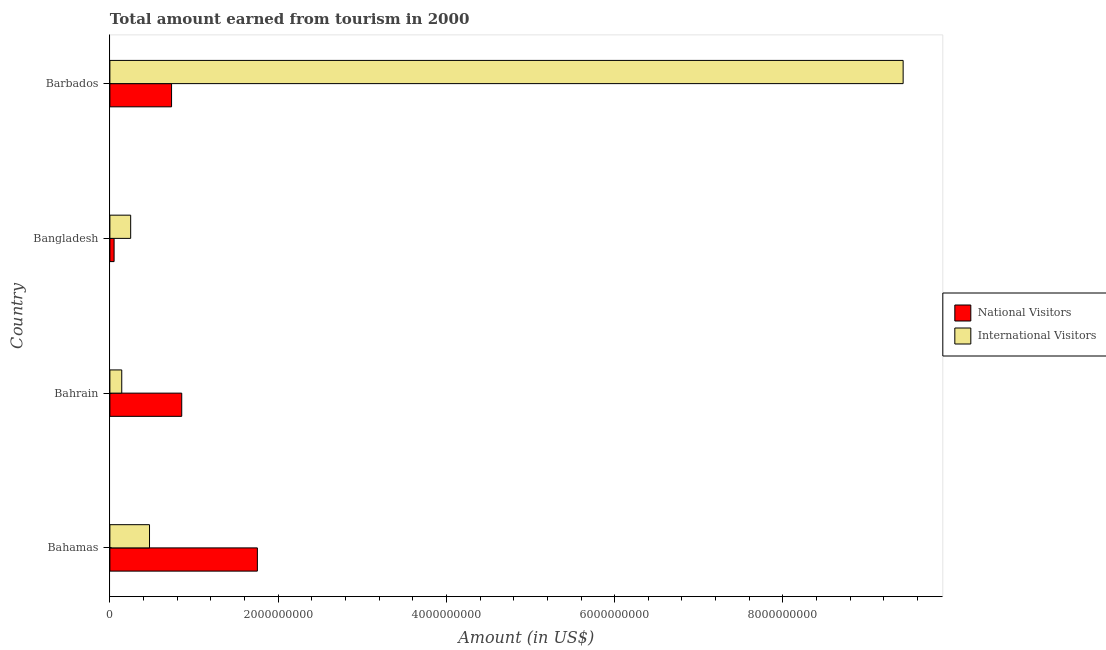How many groups of bars are there?
Your response must be concise. 4. Are the number of bars per tick equal to the number of legend labels?
Offer a very short reply. Yes. Are the number of bars on each tick of the Y-axis equal?
Your answer should be very brief. Yes. How many bars are there on the 4th tick from the top?
Make the answer very short. 2. What is the amount earned from national visitors in Bahamas?
Your response must be concise. 1.75e+09. Across all countries, what is the maximum amount earned from national visitors?
Your answer should be very brief. 1.75e+09. Across all countries, what is the minimum amount earned from international visitors?
Keep it short and to the point. 1.41e+08. In which country was the amount earned from international visitors maximum?
Offer a terse response. Barbados. In which country was the amount earned from national visitors minimum?
Make the answer very short. Bangladesh. What is the total amount earned from national visitors in the graph?
Offer a very short reply. 3.39e+09. What is the difference between the amount earned from national visitors in Bahamas and that in Bahrain?
Ensure brevity in your answer.  8.99e+08. What is the difference between the amount earned from national visitors in Bangladesh and the amount earned from international visitors in Bahamas?
Provide a short and direct response. -4.21e+08. What is the average amount earned from international visitors per country?
Ensure brevity in your answer.  2.57e+09. What is the difference between the amount earned from international visitors and amount earned from national visitors in Bahamas?
Offer a very short reply. -1.28e+09. What is the ratio of the amount earned from national visitors in Bahamas to that in Bangladesh?
Your answer should be compact. 35.06. Is the difference between the amount earned from international visitors in Bahamas and Bahrain greater than the difference between the amount earned from national visitors in Bahamas and Bahrain?
Provide a succinct answer. No. What is the difference between the highest and the second highest amount earned from national visitors?
Your response must be concise. 8.99e+08. What is the difference between the highest and the lowest amount earned from international visitors?
Provide a succinct answer. 9.29e+09. In how many countries, is the amount earned from international visitors greater than the average amount earned from international visitors taken over all countries?
Offer a terse response. 1. Is the sum of the amount earned from national visitors in Bangladesh and Barbados greater than the maximum amount earned from international visitors across all countries?
Make the answer very short. No. What does the 1st bar from the top in Bahamas represents?
Keep it short and to the point. International Visitors. What does the 2nd bar from the bottom in Bahamas represents?
Keep it short and to the point. International Visitors. What is the difference between two consecutive major ticks on the X-axis?
Your response must be concise. 2.00e+09. Are the values on the major ticks of X-axis written in scientific E-notation?
Keep it short and to the point. No. How many legend labels are there?
Provide a short and direct response. 2. How are the legend labels stacked?
Provide a short and direct response. Vertical. What is the title of the graph?
Your response must be concise. Total amount earned from tourism in 2000. What is the label or title of the X-axis?
Give a very brief answer. Amount (in US$). What is the Amount (in US$) of National Visitors in Bahamas?
Your answer should be compact. 1.75e+09. What is the Amount (in US$) of International Visitors in Bahamas?
Ensure brevity in your answer.  4.71e+08. What is the Amount (in US$) in National Visitors in Bahrain?
Offer a very short reply. 8.54e+08. What is the Amount (in US$) of International Visitors in Bahrain?
Offer a very short reply. 1.41e+08. What is the Amount (in US$) of National Visitors in Bangladesh?
Ensure brevity in your answer.  5.00e+07. What is the Amount (in US$) of International Visitors in Bangladesh?
Your response must be concise. 2.47e+08. What is the Amount (in US$) in National Visitors in Barbados?
Make the answer very short. 7.33e+08. What is the Amount (in US$) of International Visitors in Barbados?
Give a very brief answer. 9.43e+09. Across all countries, what is the maximum Amount (in US$) of National Visitors?
Keep it short and to the point. 1.75e+09. Across all countries, what is the maximum Amount (in US$) in International Visitors?
Provide a succinct answer. 9.43e+09. Across all countries, what is the minimum Amount (in US$) in National Visitors?
Offer a terse response. 5.00e+07. Across all countries, what is the minimum Amount (in US$) of International Visitors?
Give a very brief answer. 1.41e+08. What is the total Amount (in US$) in National Visitors in the graph?
Offer a terse response. 3.39e+09. What is the total Amount (in US$) in International Visitors in the graph?
Your response must be concise. 1.03e+1. What is the difference between the Amount (in US$) of National Visitors in Bahamas and that in Bahrain?
Make the answer very short. 8.99e+08. What is the difference between the Amount (in US$) of International Visitors in Bahamas and that in Bahrain?
Your answer should be compact. 3.30e+08. What is the difference between the Amount (in US$) in National Visitors in Bahamas and that in Bangladesh?
Ensure brevity in your answer.  1.70e+09. What is the difference between the Amount (in US$) of International Visitors in Bahamas and that in Bangladesh?
Offer a terse response. 2.24e+08. What is the difference between the Amount (in US$) of National Visitors in Bahamas and that in Barbados?
Provide a succinct answer. 1.02e+09. What is the difference between the Amount (in US$) of International Visitors in Bahamas and that in Barbados?
Your response must be concise. -8.96e+09. What is the difference between the Amount (in US$) of National Visitors in Bahrain and that in Bangladesh?
Your answer should be compact. 8.04e+08. What is the difference between the Amount (in US$) of International Visitors in Bahrain and that in Bangladesh?
Provide a succinct answer. -1.06e+08. What is the difference between the Amount (in US$) of National Visitors in Bahrain and that in Barbados?
Your response must be concise. 1.21e+08. What is the difference between the Amount (in US$) of International Visitors in Bahrain and that in Barbados?
Make the answer very short. -9.29e+09. What is the difference between the Amount (in US$) in National Visitors in Bangladesh and that in Barbados?
Make the answer very short. -6.83e+08. What is the difference between the Amount (in US$) of International Visitors in Bangladesh and that in Barbados?
Your answer should be compact. -9.18e+09. What is the difference between the Amount (in US$) in National Visitors in Bahamas and the Amount (in US$) in International Visitors in Bahrain?
Your answer should be compact. 1.61e+09. What is the difference between the Amount (in US$) of National Visitors in Bahamas and the Amount (in US$) of International Visitors in Bangladesh?
Give a very brief answer. 1.51e+09. What is the difference between the Amount (in US$) of National Visitors in Bahamas and the Amount (in US$) of International Visitors in Barbados?
Make the answer very short. -7.68e+09. What is the difference between the Amount (in US$) in National Visitors in Bahrain and the Amount (in US$) in International Visitors in Bangladesh?
Make the answer very short. 6.07e+08. What is the difference between the Amount (in US$) of National Visitors in Bahrain and the Amount (in US$) of International Visitors in Barbados?
Offer a very short reply. -8.58e+09. What is the difference between the Amount (in US$) of National Visitors in Bangladesh and the Amount (in US$) of International Visitors in Barbados?
Your answer should be very brief. -9.38e+09. What is the average Amount (in US$) of National Visitors per country?
Your answer should be compact. 8.48e+08. What is the average Amount (in US$) of International Visitors per country?
Your answer should be compact. 2.57e+09. What is the difference between the Amount (in US$) in National Visitors and Amount (in US$) in International Visitors in Bahamas?
Provide a short and direct response. 1.28e+09. What is the difference between the Amount (in US$) of National Visitors and Amount (in US$) of International Visitors in Bahrain?
Your answer should be very brief. 7.13e+08. What is the difference between the Amount (in US$) in National Visitors and Amount (in US$) in International Visitors in Bangladesh?
Give a very brief answer. -1.97e+08. What is the difference between the Amount (in US$) in National Visitors and Amount (in US$) in International Visitors in Barbados?
Keep it short and to the point. -8.70e+09. What is the ratio of the Amount (in US$) in National Visitors in Bahamas to that in Bahrain?
Keep it short and to the point. 2.05. What is the ratio of the Amount (in US$) in International Visitors in Bahamas to that in Bahrain?
Keep it short and to the point. 3.34. What is the ratio of the Amount (in US$) in National Visitors in Bahamas to that in Bangladesh?
Ensure brevity in your answer.  35.06. What is the ratio of the Amount (in US$) of International Visitors in Bahamas to that in Bangladesh?
Keep it short and to the point. 1.91. What is the ratio of the Amount (in US$) in National Visitors in Bahamas to that in Barbados?
Offer a very short reply. 2.39. What is the ratio of the Amount (in US$) of International Visitors in Bahamas to that in Barbados?
Make the answer very short. 0.05. What is the ratio of the Amount (in US$) of National Visitors in Bahrain to that in Bangladesh?
Provide a succinct answer. 17.08. What is the ratio of the Amount (in US$) in International Visitors in Bahrain to that in Bangladesh?
Make the answer very short. 0.57. What is the ratio of the Amount (in US$) of National Visitors in Bahrain to that in Barbados?
Your answer should be compact. 1.17. What is the ratio of the Amount (in US$) in International Visitors in Bahrain to that in Barbados?
Give a very brief answer. 0.01. What is the ratio of the Amount (in US$) of National Visitors in Bangladesh to that in Barbados?
Your answer should be compact. 0.07. What is the ratio of the Amount (in US$) of International Visitors in Bangladesh to that in Barbados?
Keep it short and to the point. 0.03. What is the difference between the highest and the second highest Amount (in US$) of National Visitors?
Provide a succinct answer. 8.99e+08. What is the difference between the highest and the second highest Amount (in US$) in International Visitors?
Ensure brevity in your answer.  8.96e+09. What is the difference between the highest and the lowest Amount (in US$) of National Visitors?
Make the answer very short. 1.70e+09. What is the difference between the highest and the lowest Amount (in US$) of International Visitors?
Offer a very short reply. 9.29e+09. 